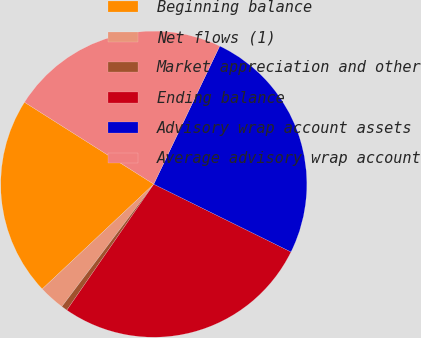Convert chart to OTSL. <chart><loc_0><loc_0><loc_500><loc_500><pie_chart><fcel>Beginning balance<fcel>Net flows (1)<fcel>Market appreciation and other<fcel>Ending balance<fcel>Advisory wrap account assets<fcel>Average advisory wrap account<nl><fcel>21.0%<fcel>2.74%<fcel>0.64%<fcel>27.31%<fcel>25.21%<fcel>23.1%<nl></chart> 